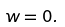Convert formula to latex. <formula><loc_0><loc_0><loc_500><loc_500>w = 0 .</formula> 